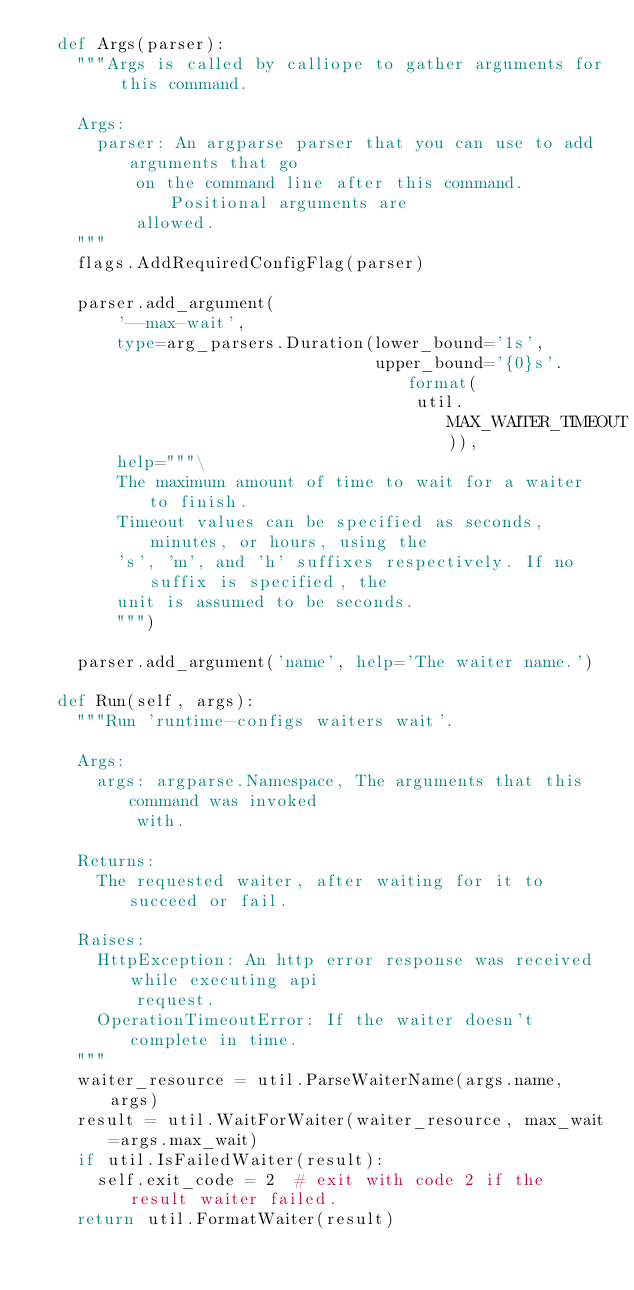Convert code to text. <code><loc_0><loc_0><loc_500><loc_500><_Python_>  def Args(parser):
    """Args is called by calliope to gather arguments for this command.

    Args:
      parser: An argparse parser that you can use to add arguments that go
          on the command line after this command. Positional arguments are
          allowed.
    """
    flags.AddRequiredConfigFlag(parser)

    parser.add_argument(
        '--max-wait',
        type=arg_parsers.Duration(lower_bound='1s',
                                  upper_bound='{0}s'.format(
                                      util.MAX_WAITER_TIMEOUT)),
        help="""\
        The maximum amount of time to wait for a waiter to finish.
        Timeout values can be specified as seconds, minutes, or hours, using the
        's', 'm', and 'h' suffixes respectively. If no suffix is specified, the
        unit is assumed to be seconds.
        """)

    parser.add_argument('name', help='The waiter name.')

  def Run(self, args):
    """Run 'runtime-configs waiters wait'.

    Args:
      args: argparse.Namespace, The arguments that this command was invoked
          with.

    Returns:
      The requested waiter, after waiting for it to succeed or fail.

    Raises:
      HttpException: An http error response was received while executing api
          request.
      OperationTimeoutError: If the waiter doesn't complete in time.
    """
    waiter_resource = util.ParseWaiterName(args.name, args)
    result = util.WaitForWaiter(waiter_resource, max_wait=args.max_wait)
    if util.IsFailedWaiter(result):
      self.exit_code = 2  # exit with code 2 if the result waiter failed.
    return util.FormatWaiter(result)
</code> 